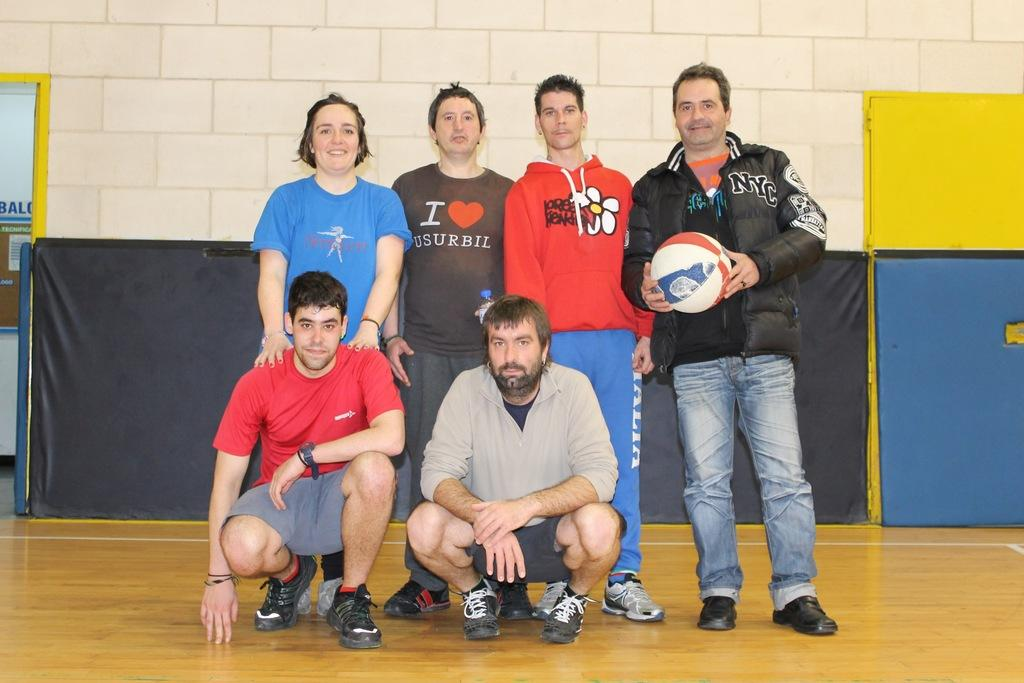How many people are present in the image? There are six people in the image, four standing and two sitting. What are the people in the image doing? The people are either standing or sitting. What can be seen in the background of the image? There is a wall in the background of the image. What type of locket is hanging from the wall in the image? There is no locket hanging from the wall in the image. How hot is the temperature in the image? The temperature is not mentioned in the image, so it cannot be determined. 